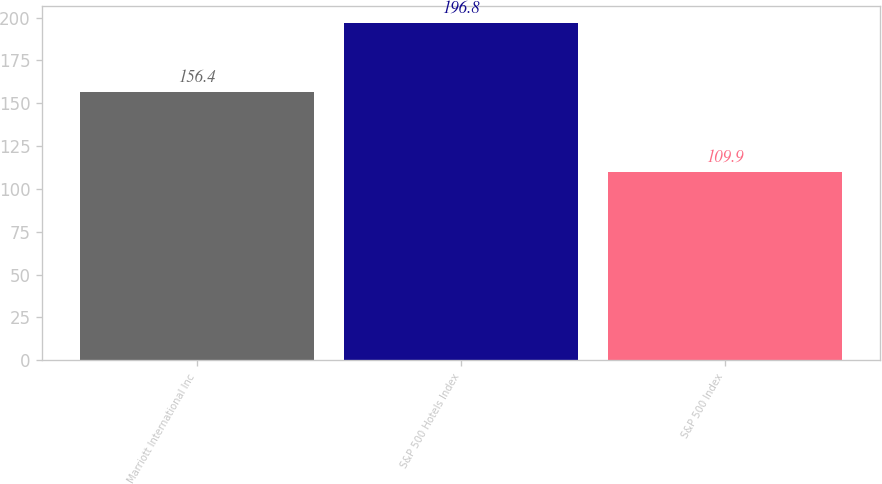Convert chart. <chart><loc_0><loc_0><loc_500><loc_500><bar_chart><fcel>Marriott International Inc<fcel>S&P 500 Hotels Index<fcel>S&P 500 Index<nl><fcel>156.4<fcel>196.8<fcel>109.9<nl></chart> 